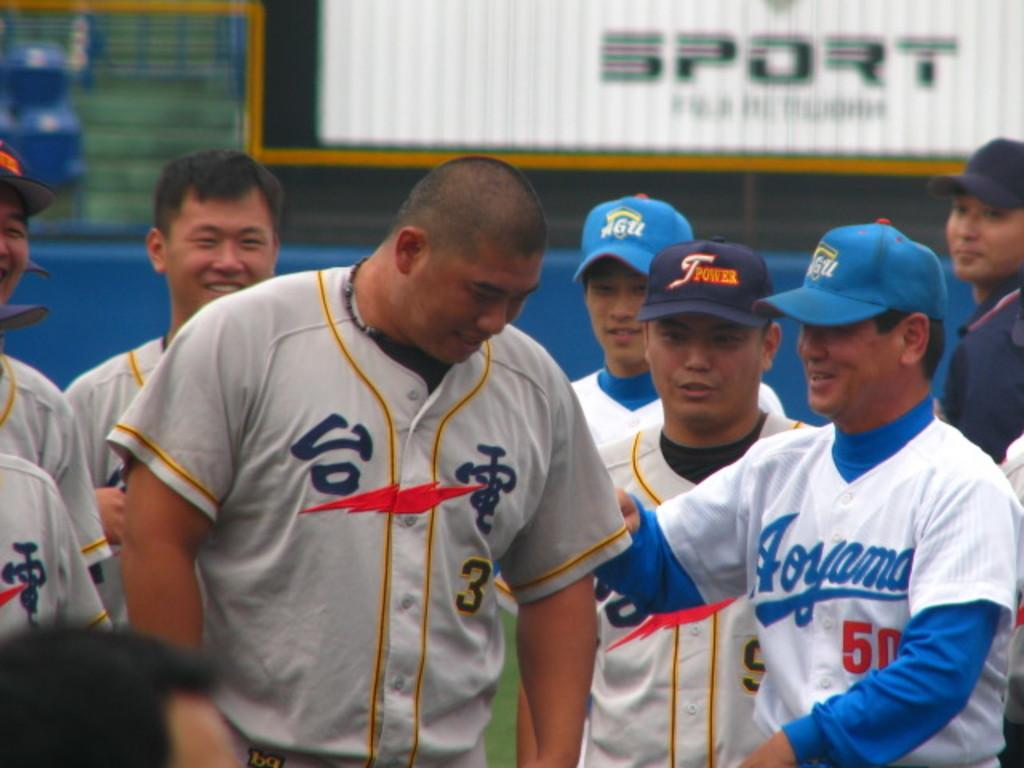<image>
Create a compact narrative representing the image presented. player 50 for aojama consoling Tpower player #3 